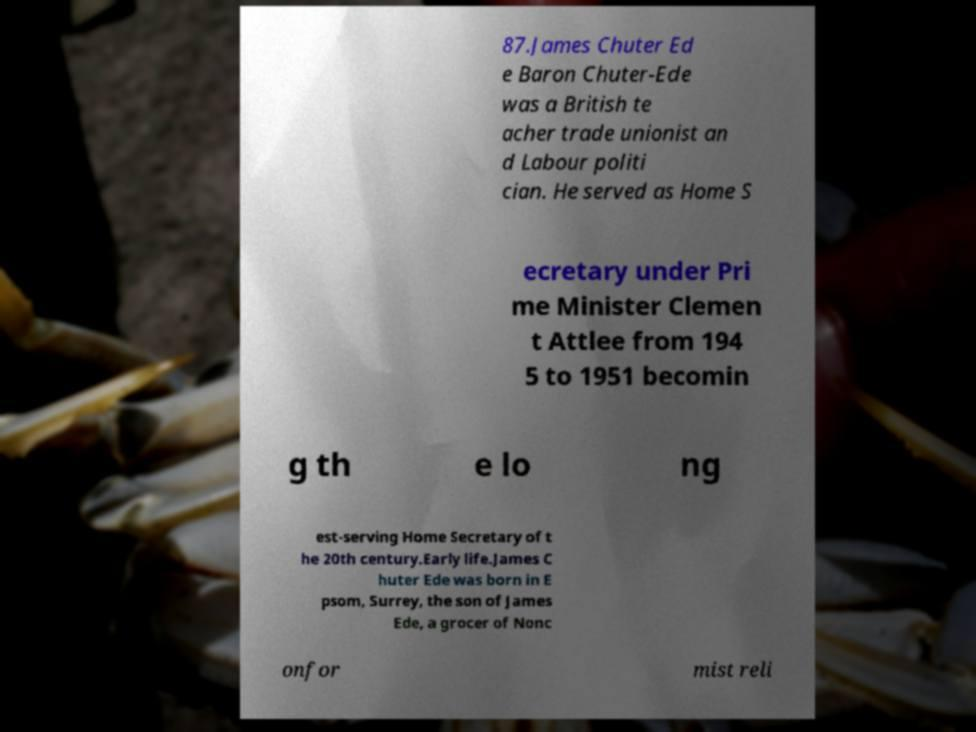I need the written content from this picture converted into text. Can you do that? 87.James Chuter Ed e Baron Chuter-Ede was a British te acher trade unionist an d Labour politi cian. He served as Home S ecretary under Pri me Minister Clemen t Attlee from 194 5 to 1951 becomin g th e lo ng est-serving Home Secretary of t he 20th century.Early life.James C huter Ede was born in E psom, Surrey, the son of James Ede, a grocer of Nonc onfor mist reli 